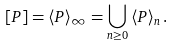Convert formula to latex. <formula><loc_0><loc_0><loc_500><loc_500>[ P ] = \left \langle P \right \rangle _ { \infty } = \bigcup _ { n \geq 0 } \left \langle P \right \rangle _ { n } .</formula> 